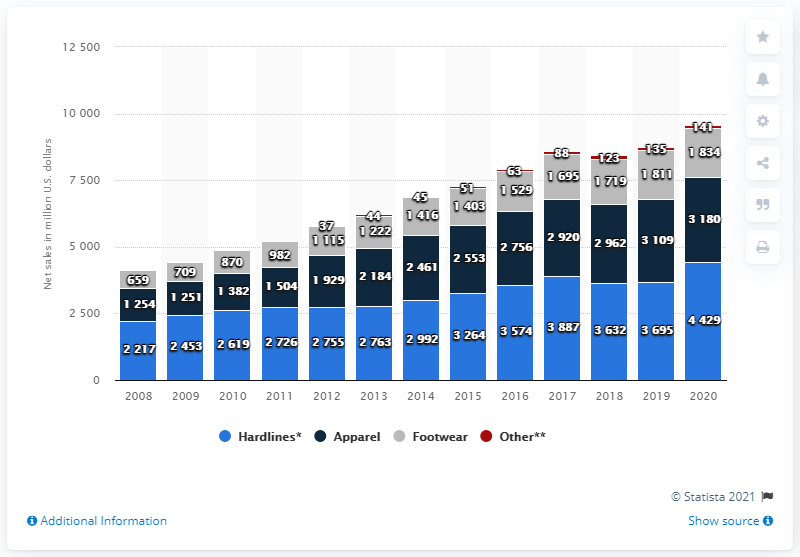Mention a couple of crucial points in this snapshot. The apparel sales of Dick's Sporting Goods in the fiscal year of 2020 were approximately 3,180. 